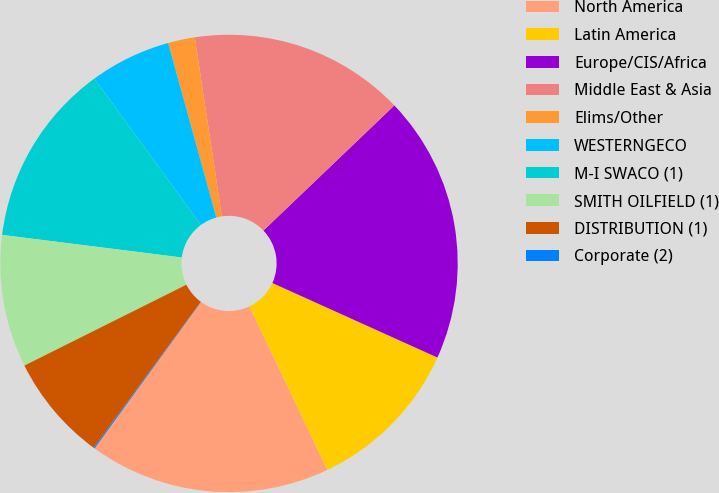Convert chart to OTSL. <chart><loc_0><loc_0><loc_500><loc_500><pie_chart><fcel>North America<fcel>Latin America<fcel>Europe/CIS/Africa<fcel>Middle East & Asia<fcel>Elims/Other<fcel>WESTERNGECO<fcel>M-I SWACO (1)<fcel>SMITH OILFIELD (1)<fcel>DISTRIBUTION (1)<fcel>Corporate (2)<nl><fcel>17.07%<fcel>11.18%<fcel>18.89%<fcel>15.25%<fcel>1.9%<fcel>5.73%<fcel>12.99%<fcel>9.36%<fcel>7.55%<fcel>0.08%<nl></chart> 